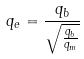<formula> <loc_0><loc_0><loc_500><loc_500>q _ { e } = \frac { q _ { b } } { \sqrt { \frac { q _ { b } } { q _ { m } } } }</formula> 